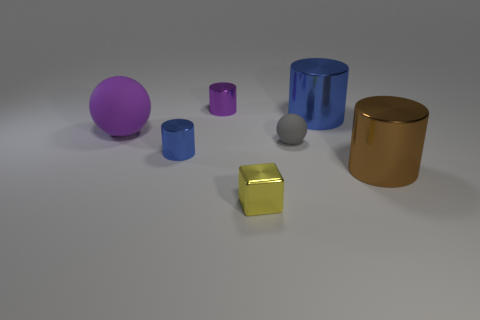Subtract 1 cylinders. How many cylinders are left? 3 Add 3 cyan cylinders. How many objects exist? 10 Subtract all cyan cylinders. Subtract all green spheres. How many cylinders are left? 4 Subtract all cylinders. How many objects are left? 3 Subtract all tiny rubber objects. Subtract all metal objects. How many objects are left? 1 Add 6 big purple rubber balls. How many big purple rubber balls are left? 7 Add 7 tiny green cubes. How many tiny green cubes exist? 7 Subtract 0 green blocks. How many objects are left? 7 